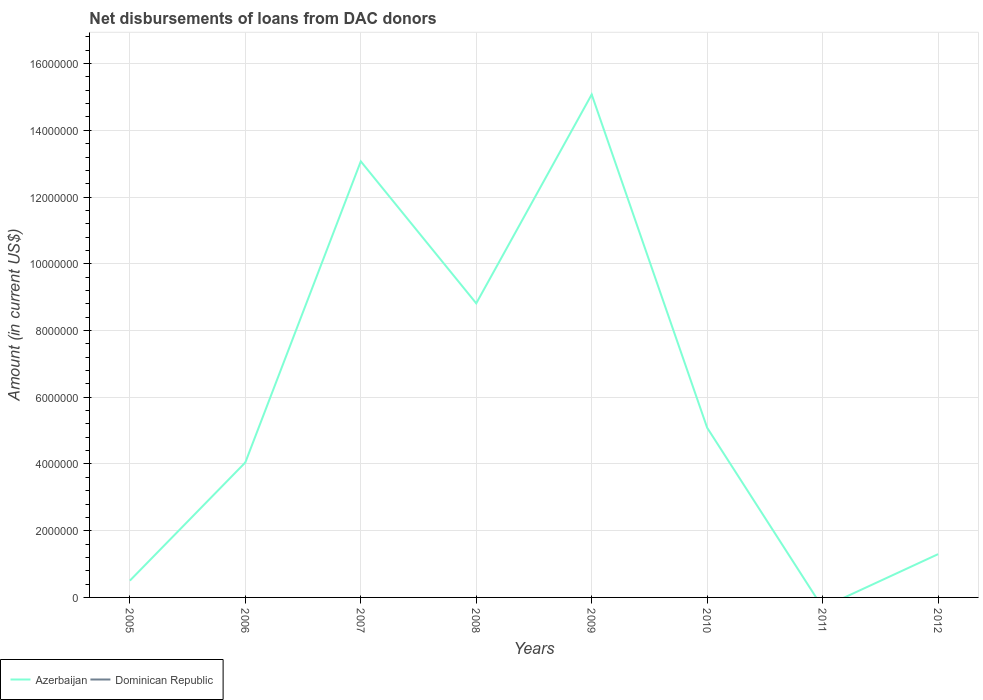Does the line corresponding to Azerbaijan intersect with the line corresponding to Dominican Republic?
Provide a succinct answer. No. Is the number of lines equal to the number of legend labels?
Your answer should be compact. No. What is the total amount of loans disbursed in Azerbaijan in the graph?
Your response must be concise. 4.26e+06. What is the difference between the highest and the second highest amount of loans disbursed in Azerbaijan?
Provide a succinct answer. 1.51e+07. Is the amount of loans disbursed in Azerbaijan strictly greater than the amount of loans disbursed in Dominican Republic over the years?
Keep it short and to the point. No. How many years are there in the graph?
Offer a terse response. 8. Are the values on the major ticks of Y-axis written in scientific E-notation?
Your answer should be very brief. No. Where does the legend appear in the graph?
Make the answer very short. Bottom left. How many legend labels are there?
Ensure brevity in your answer.  2. What is the title of the graph?
Keep it short and to the point. Net disbursements of loans from DAC donors. Does "Timor-Leste" appear as one of the legend labels in the graph?
Your response must be concise. No. What is the Amount (in current US$) in Azerbaijan in 2005?
Ensure brevity in your answer.  5.03e+05. What is the Amount (in current US$) of Azerbaijan in 2006?
Offer a very short reply. 4.04e+06. What is the Amount (in current US$) in Dominican Republic in 2006?
Give a very brief answer. 0. What is the Amount (in current US$) of Azerbaijan in 2007?
Your response must be concise. 1.31e+07. What is the Amount (in current US$) in Azerbaijan in 2008?
Make the answer very short. 8.81e+06. What is the Amount (in current US$) in Azerbaijan in 2009?
Offer a very short reply. 1.51e+07. What is the Amount (in current US$) of Azerbaijan in 2010?
Give a very brief answer. 5.08e+06. What is the Amount (in current US$) of Azerbaijan in 2012?
Make the answer very short. 1.30e+06. What is the Amount (in current US$) in Dominican Republic in 2012?
Your answer should be very brief. 0. Across all years, what is the maximum Amount (in current US$) in Azerbaijan?
Give a very brief answer. 1.51e+07. What is the total Amount (in current US$) in Azerbaijan in the graph?
Offer a very short reply. 4.79e+07. What is the difference between the Amount (in current US$) of Azerbaijan in 2005 and that in 2006?
Ensure brevity in your answer.  -3.54e+06. What is the difference between the Amount (in current US$) of Azerbaijan in 2005 and that in 2007?
Provide a short and direct response. -1.26e+07. What is the difference between the Amount (in current US$) in Azerbaijan in 2005 and that in 2008?
Offer a very short reply. -8.31e+06. What is the difference between the Amount (in current US$) in Azerbaijan in 2005 and that in 2009?
Keep it short and to the point. -1.46e+07. What is the difference between the Amount (in current US$) of Azerbaijan in 2005 and that in 2010?
Ensure brevity in your answer.  -4.58e+06. What is the difference between the Amount (in current US$) of Azerbaijan in 2005 and that in 2012?
Ensure brevity in your answer.  -7.94e+05. What is the difference between the Amount (in current US$) of Azerbaijan in 2006 and that in 2007?
Give a very brief answer. -9.02e+06. What is the difference between the Amount (in current US$) in Azerbaijan in 2006 and that in 2008?
Your answer should be compact. -4.77e+06. What is the difference between the Amount (in current US$) of Azerbaijan in 2006 and that in 2009?
Your answer should be compact. -1.10e+07. What is the difference between the Amount (in current US$) of Azerbaijan in 2006 and that in 2010?
Make the answer very short. -1.04e+06. What is the difference between the Amount (in current US$) of Azerbaijan in 2006 and that in 2012?
Offer a very short reply. 2.75e+06. What is the difference between the Amount (in current US$) of Azerbaijan in 2007 and that in 2008?
Offer a very short reply. 4.26e+06. What is the difference between the Amount (in current US$) of Azerbaijan in 2007 and that in 2009?
Give a very brief answer. -2.00e+06. What is the difference between the Amount (in current US$) of Azerbaijan in 2007 and that in 2010?
Your response must be concise. 7.98e+06. What is the difference between the Amount (in current US$) of Azerbaijan in 2007 and that in 2012?
Your answer should be very brief. 1.18e+07. What is the difference between the Amount (in current US$) of Azerbaijan in 2008 and that in 2009?
Ensure brevity in your answer.  -6.26e+06. What is the difference between the Amount (in current US$) in Azerbaijan in 2008 and that in 2010?
Ensure brevity in your answer.  3.73e+06. What is the difference between the Amount (in current US$) of Azerbaijan in 2008 and that in 2012?
Ensure brevity in your answer.  7.52e+06. What is the difference between the Amount (in current US$) of Azerbaijan in 2009 and that in 2010?
Offer a terse response. 9.99e+06. What is the difference between the Amount (in current US$) in Azerbaijan in 2009 and that in 2012?
Offer a very short reply. 1.38e+07. What is the difference between the Amount (in current US$) in Azerbaijan in 2010 and that in 2012?
Your answer should be very brief. 3.79e+06. What is the average Amount (in current US$) in Azerbaijan per year?
Offer a very short reply. 5.99e+06. What is the average Amount (in current US$) in Dominican Republic per year?
Provide a succinct answer. 0. What is the ratio of the Amount (in current US$) in Azerbaijan in 2005 to that in 2006?
Make the answer very short. 0.12. What is the ratio of the Amount (in current US$) in Azerbaijan in 2005 to that in 2007?
Keep it short and to the point. 0.04. What is the ratio of the Amount (in current US$) of Azerbaijan in 2005 to that in 2008?
Make the answer very short. 0.06. What is the ratio of the Amount (in current US$) of Azerbaijan in 2005 to that in 2009?
Give a very brief answer. 0.03. What is the ratio of the Amount (in current US$) of Azerbaijan in 2005 to that in 2010?
Offer a very short reply. 0.1. What is the ratio of the Amount (in current US$) of Azerbaijan in 2005 to that in 2012?
Make the answer very short. 0.39. What is the ratio of the Amount (in current US$) in Azerbaijan in 2006 to that in 2007?
Your answer should be compact. 0.31. What is the ratio of the Amount (in current US$) of Azerbaijan in 2006 to that in 2008?
Make the answer very short. 0.46. What is the ratio of the Amount (in current US$) in Azerbaijan in 2006 to that in 2009?
Provide a short and direct response. 0.27. What is the ratio of the Amount (in current US$) in Azerbaijan in 2006 to that in 2010?
Offer a very short reply. 0.8. What is the ratio of the Amount (in current US$) of Azerbaijan in 2006 to that in 2012?
Provide a succinct answer. 3.12. What is the ratio of the Amount (in current US$) of Azerbaijan in 2007 to that in 2008?
Offer a terse response. 1.48. What is the ratio of the Amount (in current US$) in Azerbaijan in 2007 to that in 2009?
Your response must be concise. 0.87. What is the ratio of the Amount (in current US$) in Azerbaijan in 2007 to that in 2010?
Give a very brief answer. 2.57. What is the ratio of the Amount (in current US$) in Azerbaijan in 2007 to that in 2012?
Your response must be concise. 10.08. What is the ratio of the Amount (in current US$) in Azerbaijan in 2008 to that in 2009?
Offer a terse response. 0.58. What is the ratio of the Amount (in current US$) in Azerbaijan in 2008 to that in 2010?
Your response must be concise. 1.73. What is the ratio of the Amount (in current US$) of Azerbaijan in 2008 to that in 2012?
Your response must be concise. 6.8. What is the ratio of the Amount (in current US$) of Azerbaijan in 2009 to that in 2010?
Provide a succinct answer. 2.96. What is the ratio of the Amount (in current US$) of Azerbaijan in 2009 to that in 2012?
Your answer should be compact. 11.62. What is the ratio of the Amount (in current US$) in Azerbaijan in 2010 to that in 2012?
Your answer should be very brief. 3.92. What is the difference between the highest and the second highest Amount (in current US$) of Azerbaijan?
Provide a succinct answer. 2.00e+06. What is the difference between the highest and the lowest Amount (in current US$) of Azerbaijan?
Offer a terse response. 1.51e+07. 